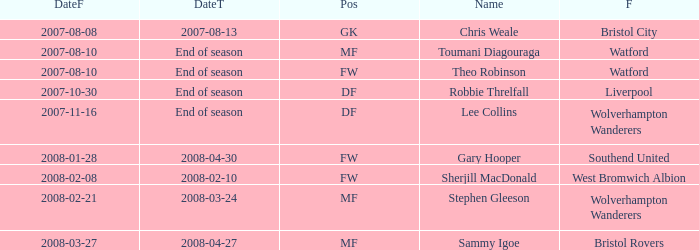What date did Toumani Diagouraga, who played position MF, start? 2007-08-10. 